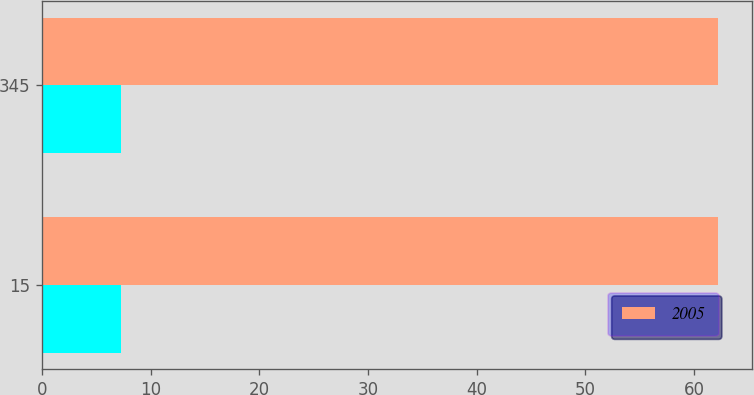<chart> <loc_0><loc_0><loc_500><loc_500><stacked_bar_chart><ecel><fcel>15<fcel>345<nl><fcel>nan<fcel>7.3<fcel>7.3<nl><fcel>2005<fcel>62.2<fcel>62.2<nl></chart> 